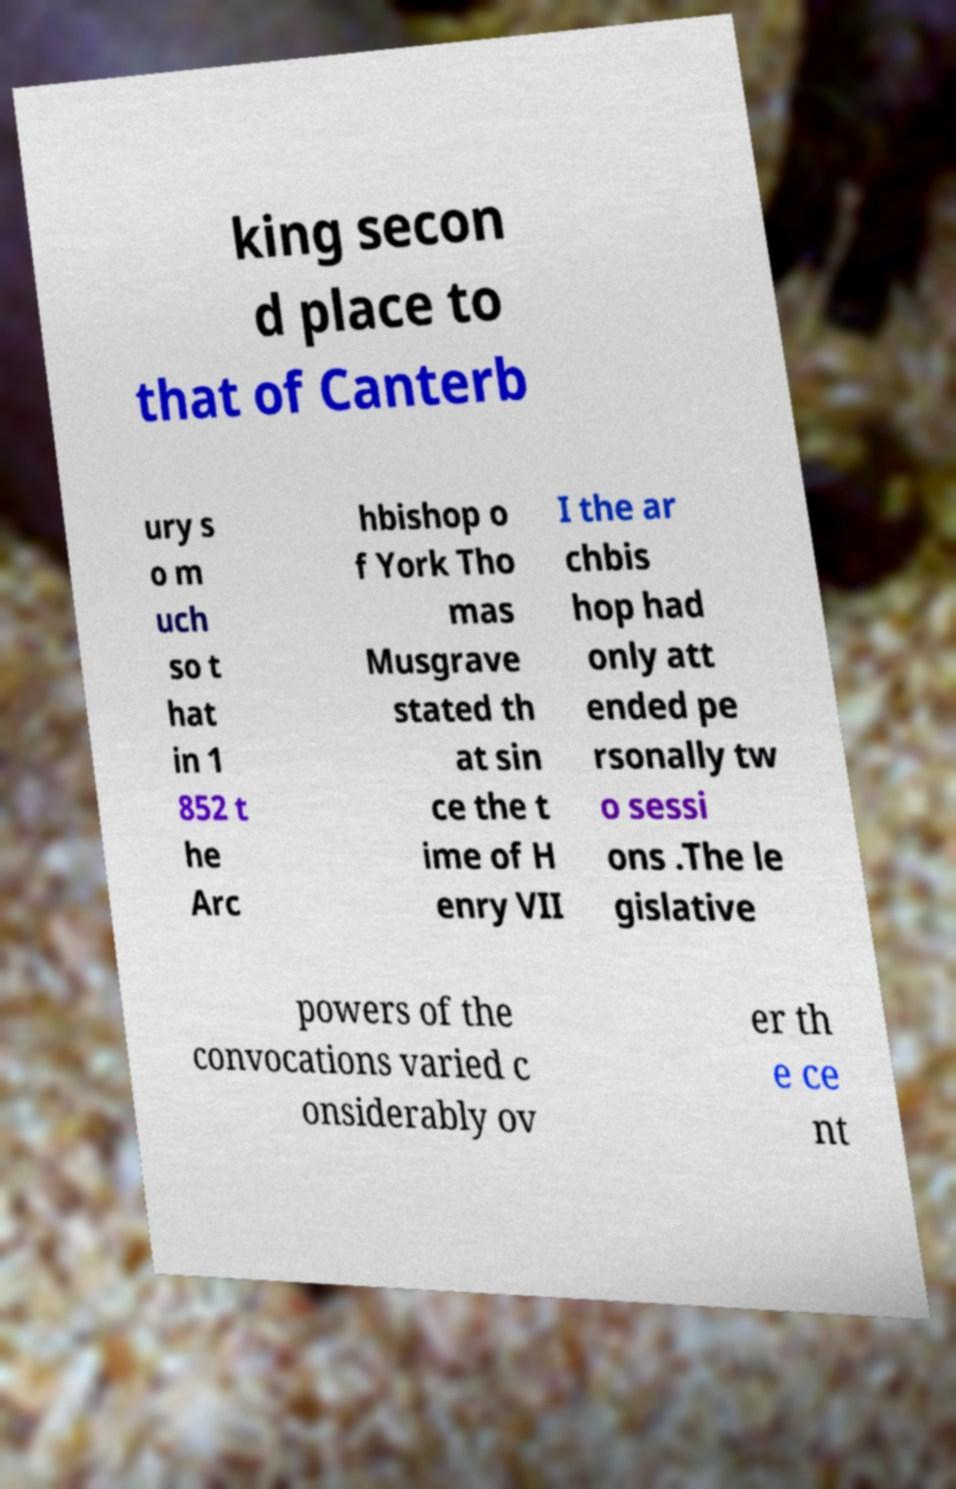I need the written content from this picture converted into text. Can you do that? king secon d place to that of Canterb ury s o m uch so t hat in 1 852 t he Arc hbishop o f York Tho mas Musgrave stated th at sin ce the t ime of H enry VII I the ar chbis hop had only att ended pe rsonally tw o sessi ons .The le gislative powers of the convocations varied c onsiderably ov er th e ce nt 